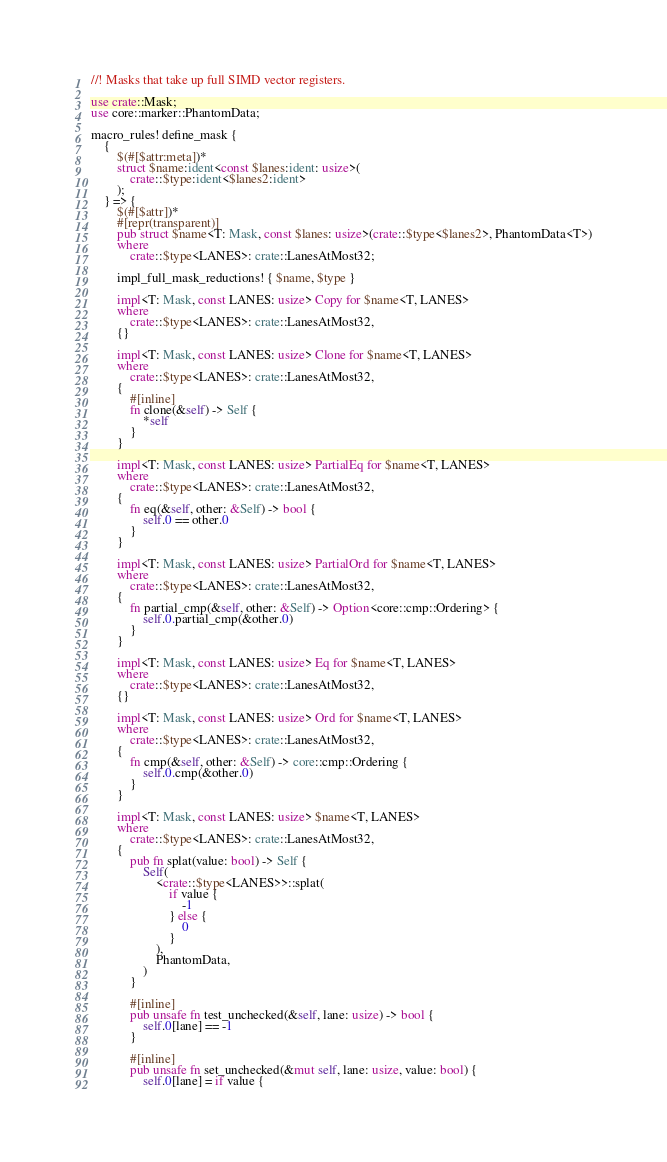Convert code to text. <code><loc_0><loc_0><loc_500><loc_500><_Rust_>//! Masks that take up full SIMD vector registers.

use crate::Mask;
use core::marker::PhantomData;

macro_rules! define_mask {
    {
        $(#[$attr:meta])*
        struct $name:ident<const $lanes:ident: usize>(
            crate::$type:ident<$lanes2:ident>
        );
    } => {
        $(#[$attr])*
        #[repr(transparent)]
        pub struct $name<T: Mask, const $lanes: usize>(crate::$type<$lanes2>, PhantomData<T>)
        where
            crate::$type<LANES>: crate::LanesAtMost32;

        impl_full_mask_reductions! { $name, $type }

        impl<T: Mask, const LANES: usize> Copy for $name<T, LANES>
        where
            crate::$type<LANES>: crate::LanesAtMost32,
        {}

        impl<T: Mask, const LANES: usize> Clone for $name<T, LANES>
        where
            crate::$type<LANES>: crate::LanesAtMost32,
        {
            #[inline]
            fn clone(&self) -> Self {
                *self
            }
        }

        impl<T: Mask, const LANES: usize> PartialEq for $name<T, LANES>
        where
            crate::$type<LANES>: crate::LanesAtMost32,
        {
            fn eq(&self, other: &Self) -> bool {
                self.0 == other.0
            }
        }

        impl<T: Mask, const LANES: usize> PartialOrd for $name<T, LANES>
        where
            crate::$type<LANES>: crate::LanesAtMost32,
        {
            fn partial_cmp(&self, other: &Self) -> Option<core::cmp::Ordering> {
                self.0.partial_cmp(&other.0)
            }
        }

        impl<T: Mask, const LANES: usize> Eq for $name<T, LANES>
        where
            crate::$type<LANES>: crate::LanesAtMost32,
        {}

        impl<T: Mask, const LANES: usize> Ord for $name<T, LANES>
        where
            crate::$type<LANES>: crate::LanesAtMost32,
        {
            fn cmp(&self, other: &Self) -> core::cmp::Ordering {
                self.0.cmp(&other.0)
            }
        }

        impl<T: Mask, const LANES: usize> $name<T, LANES>
        where
            crate::$type<LANES>: crate::LanesAtMost32,
        {
            pub fn splat(value: bool) -> Self {
                Self(
                    <crate::$type<LANES>>::splat(
                        if value {
                            -1
                        } else {
                            0
                        }
                    ),
                    PhantomData,
                )
            }

            #[inline]
            pub unsafe fn test_unchecked(&self, lane: usize) -> bool {
                self.0[lane] == -1
            }

            #[inline]
            pub unsafe fn set_unchecked(&mut self, lane: usize, value: bool) {
                self.0[lane] = if value {</code> 